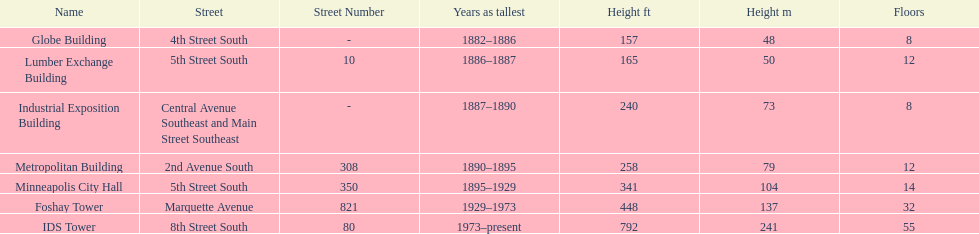How many buildings on the list are taller than 200 feet? 5. 